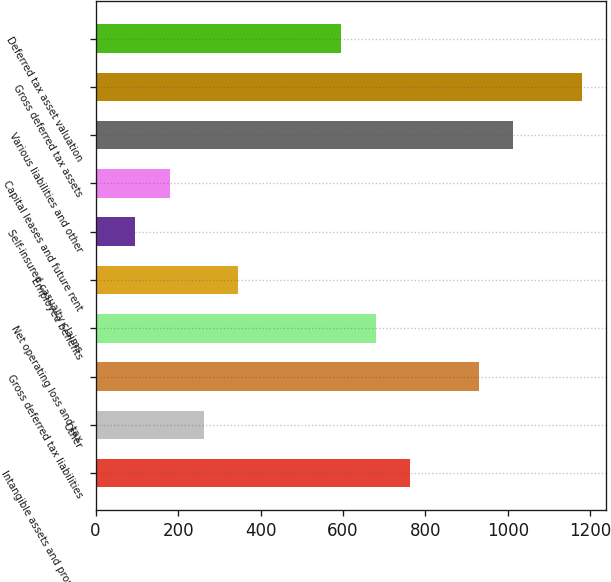Convert chart. <chart><loc_0><loc_0><loc_500><loc_500><bar_chart><fcel>Intangible assets and property<fcel>Other<fcel>Gross deferred tax liabilities<fcel>Net operating loss and tax<fcel>Employee benefits<fcel>Self-insured casualty claims<fcel>Capital leases and future rent<fcel>Various liabilities and other<fcel>Gross deferred tax assets<fcel>Deferred tax asset valuation<nl><fcel>762.7<fcel>262.9<fcel>929.3<fcel>679.4<fcel>346.2<fcel>96.3<fcel>179.6<fcel>1012.6<fcel>1179.2<fcel>596.1<nl></chart> 